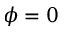<formula> <loc_0><loc_0><loc_500><loc_500>\phi = 0</formula> 